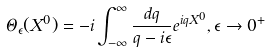<formula> <loc_0><loc_0><loc_500><loc_500>\Theta _ { \epsilon } ( X ^ { 0 } ) = - i \int _ { - \infty } ^ { \infty } \frac { d q } { q - i \epsilon } e ^ { i q X ^ { 0 } } , \epsilon \rightarrow 0 ^ { + }</formula> 